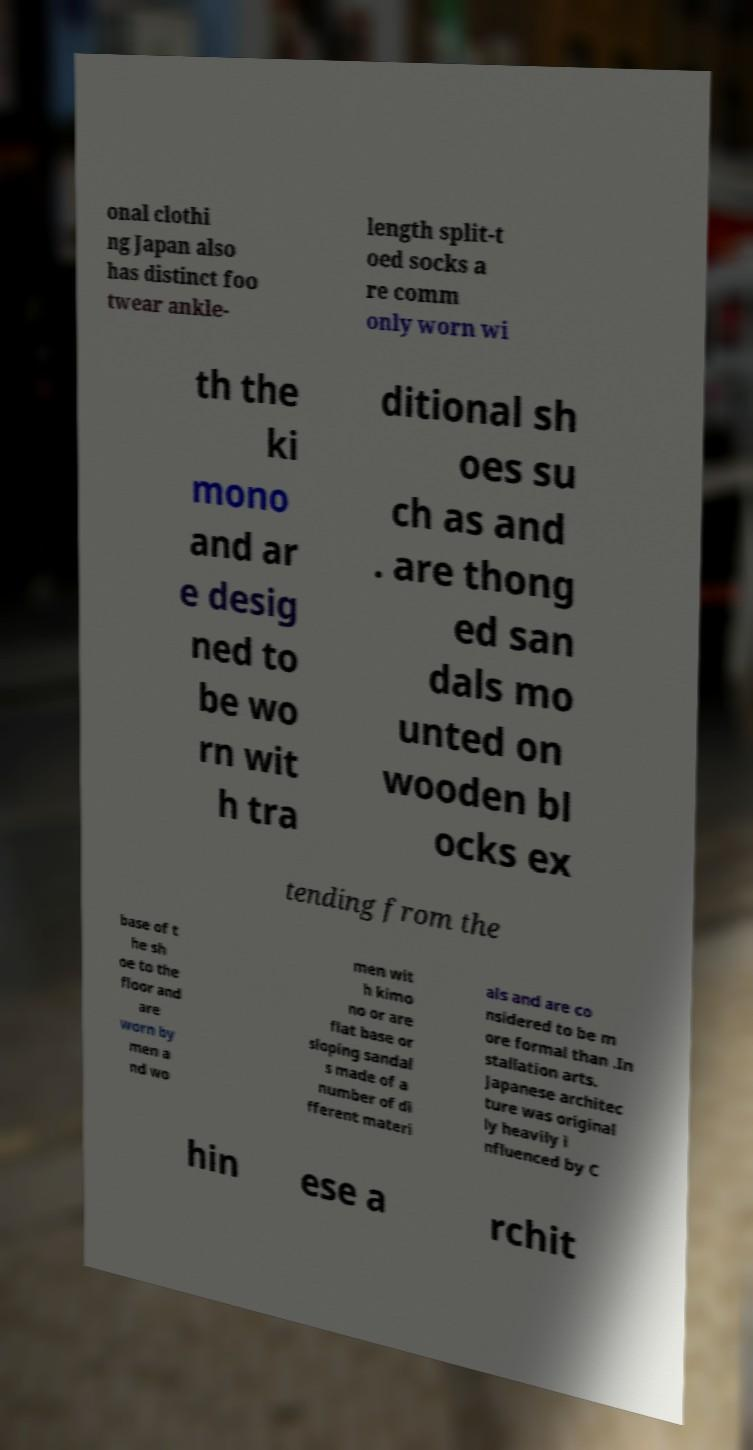Can you accurately transcribe the text from the provided image for me? onal clothi ng Japan also has distinct foo twear ankle- length split-t oed socks a re comm only worn wi th the ki mono and ar e desig ned to be wo rn wit h tra ditional sh oes su ch as and . are thong ed san dals mo unted on wooden bl ocks ex tending from the base of t he sh oe to the floor and are worn by men a nd wo men wit h kimo no or are flat base or sloping sandal s made of a number of di fferent materi als and are co nsidered to be m ore formal than .In stallation arts. Japanese architec ture was original ly heavily i nfluenced by C hin ese a rchit 